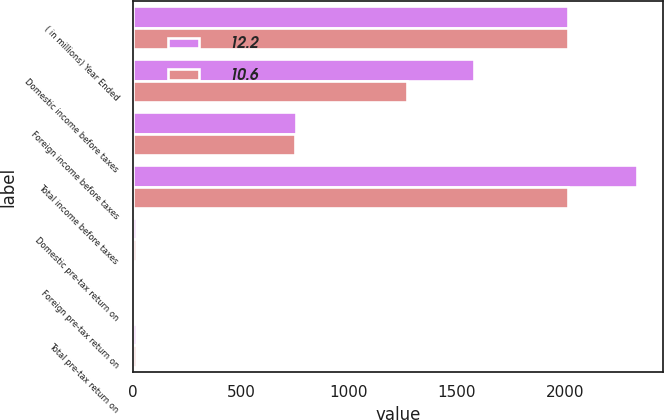<chart> <loc_0><loc_0><loc_500><loc_500><stacked_bar_chart><ecel><fcel>( in millions) Year Ended<fcel>Domestic income before taxes<fcel>Foreign income before taxes<fcel>Total income before taxes<fcel>Domestic pre-tax return on<fcel>Foreign pre-tax return on<fcel>Total pre-tax return on<nl><fcel>12.2<fcel>2015<fcel>1581.6<fcel>755.5<fcel>2337.1<fcel>13.7<fcel>9.9<fcel>12.2<nl><fcel>10.6<fcel>2014<fcel>1267.3<fcel>750.3<fcel>2017.6<fcel>12.4<fcel>8.6<fcel>10.6<nl></chart> 